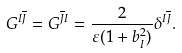Convert formula to latex. <formula><loc_0><loc_0><loc_500><loc_500>G ^ { I \overline { J } } = G ^ { \overline { J } I } = \frac { 2 } { \varepsilon ( 1 + b ^ { 2 } _ { I } ) } \delta ^ { I \overline { J } } .</formula> 